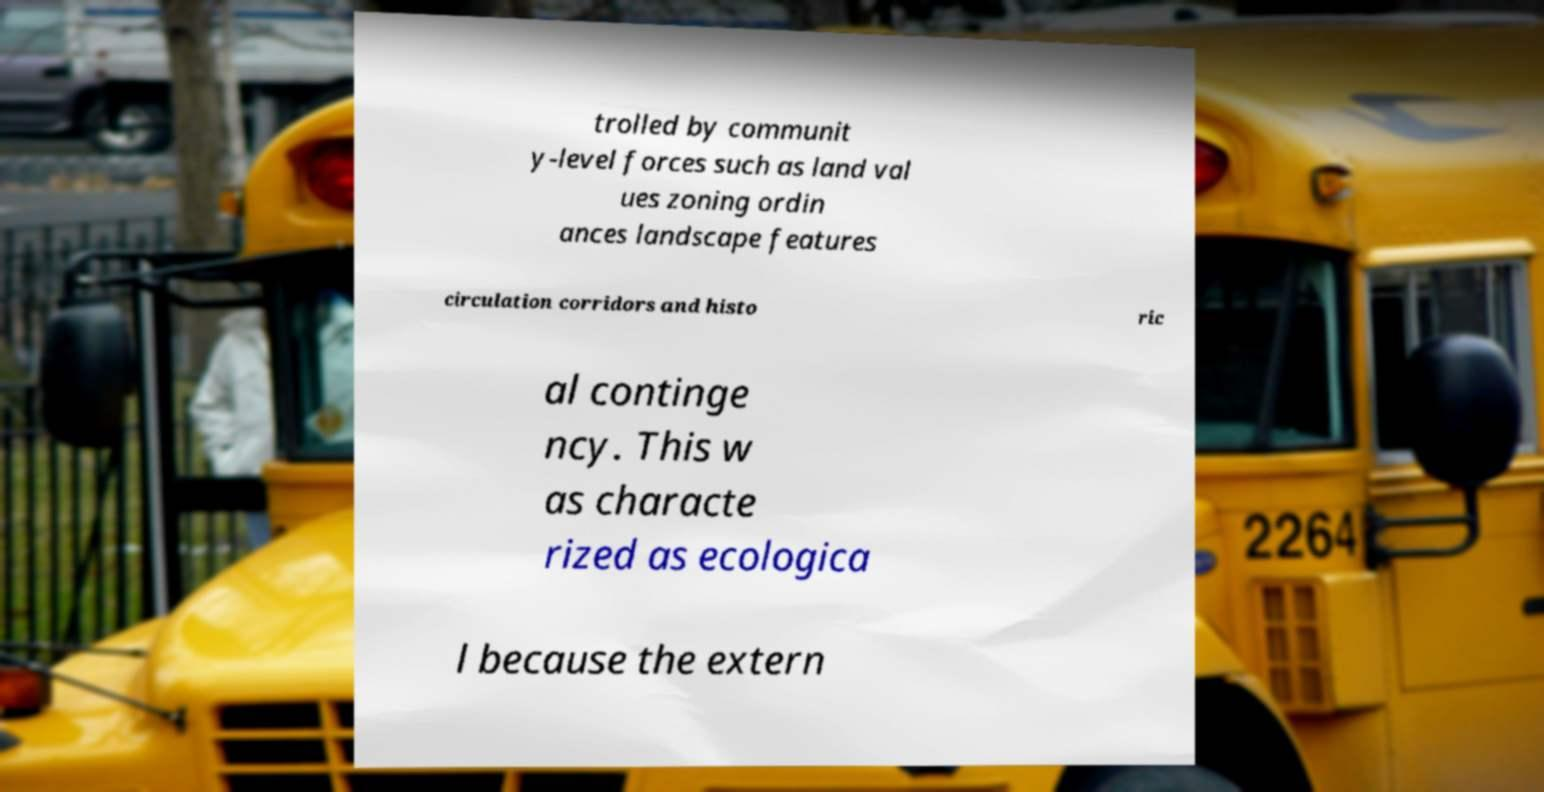Please read and relay the text visible in this image. What does it say? trolled by communit y-level forces such as land val ues zoning ordin ances landscape features circulation corridors and histo ric al continge ncy. This w as characte rized as ecologica l because the extern 